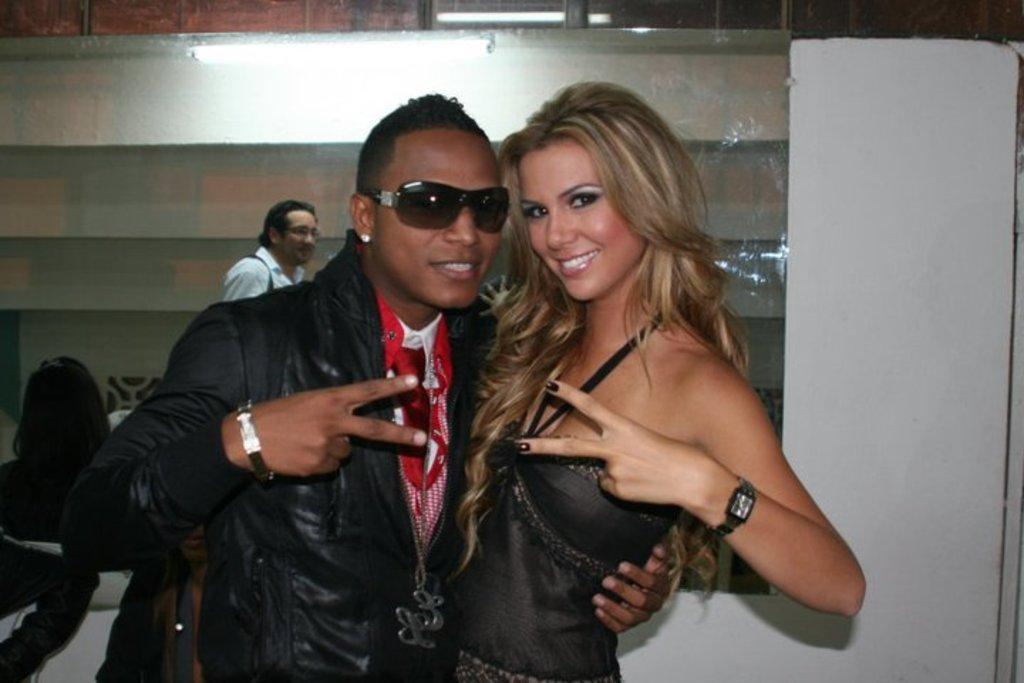How would you summarize this image in a sentence or two? In this picture I can see a man and a woman standing and smiling, and in the background there is a mirror attached to the wall, and there is a reflection of group of people and a light on the mirror. 